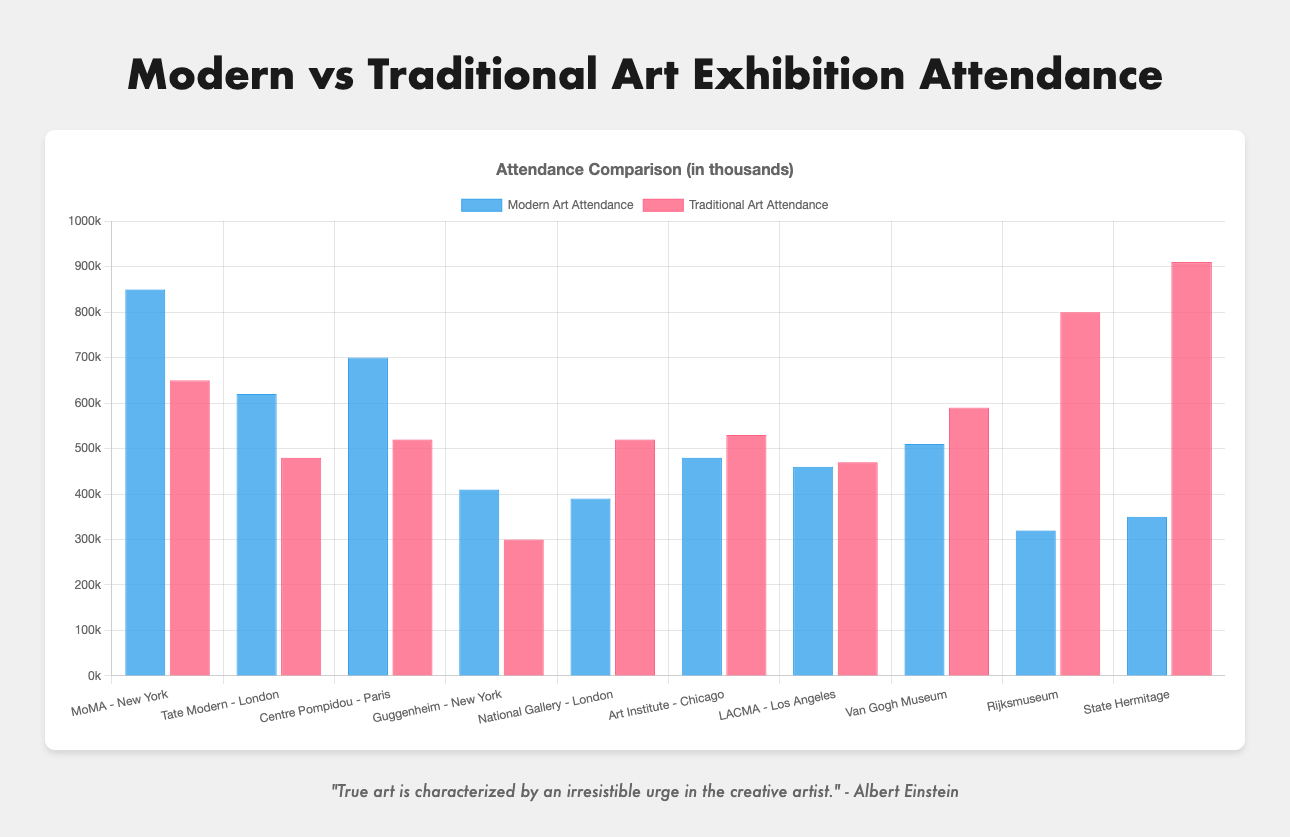How does the attendance for modern art exhibitions compare to traditional art at the Guggenheim Museum in New York? Modern art attendance (410,000) is higher than traditional art attendance (300,000) at the Guggenheim Museum.
Answer: Modern art is higher by 110,000 Which museum has the highest attendance for traditional art exhibitions? The State Hermitage Museum in St. Petersburg has the highest traditional art attendance, with 910,000.
Answer: State Hermitage Museum How many museums have higher attendance for traditional art exhibitions than for modern art exhibitions? Comparing the values, 6 museums have higher traditional art attendance: National Gallery, Art Institute of Chicago, LACMA, Van Gogh Museum, Rijksmuseum, and State Hermitage Museum.
Answer: 6 What is the overall average attendance for modern art exhibitions across all museums? Sum modern art attendances (850,000 + 620,000 + 700,000 + 410,000 + 390,000 + 480,000 + 460,000 + 510,000 + 320,000 + 350,000 = 5,090,000), divide by the number of museums (10), so the average is 5,090,000 / 10 = 509,000.
Answer: 509,000 Which museum has the largest difference in attendance between modern art and traditional art exhibitions? Calculate the absolute difference for each museum: MoMA (200,000), Tate Modern (140,000), Centre Pompidou (180,000), Guggenheim (110,000), National Gallery (130,000), Art Institute (50,000), LACMA (10,000), Van Gogh (80,000), Rijksmuseum (480,000), State Hermitage (560,000). The State Hermitage has the largest difference (560,000).
Answer: State Hermitage Museum Identify the museum where modern art exhibitions have higher attendance than traditional, but with the smallest margin. Calculate the positive differences for museums where modern art is higher: MoMA (200,000), Tate Modern (140,000), Centre Pompidou (180,000), Guggenheim (110,000). Guggenheim has the smallest difference 110,000.
Answer: Guggenheim Museum What is the total attendance for both modern and traditional art exhibitions at Centre Pompidou in Paris? Modern art (700,000) + Traditional art (520,000) = 1,220,000.
Answer: 1,220,000 How does the attendance at the Van Gogh Museum in Amsterdam compare between modern art and traditional art? For modern art (510,000) vs traditional art (590,000). Traditional art attendance is higher by 80,000.
Answer: Traditional art is higher by 80,000 What is the range of attendance figures for modern art across all museums? Identify the maximum (850,000, MoMA) and minimum (320,000, Rijksmuseum) values. The range is 850,000 - 320,000 = 530,000.
Answer: 530,000 Between which museums is the modern art attendance almost equal, and what is the difference? Compare similar values: Art Institute (480,000) and LACMA (460,000) differ by 20,000.
Answer: Art Institute and LACMA, difference is 20,000 